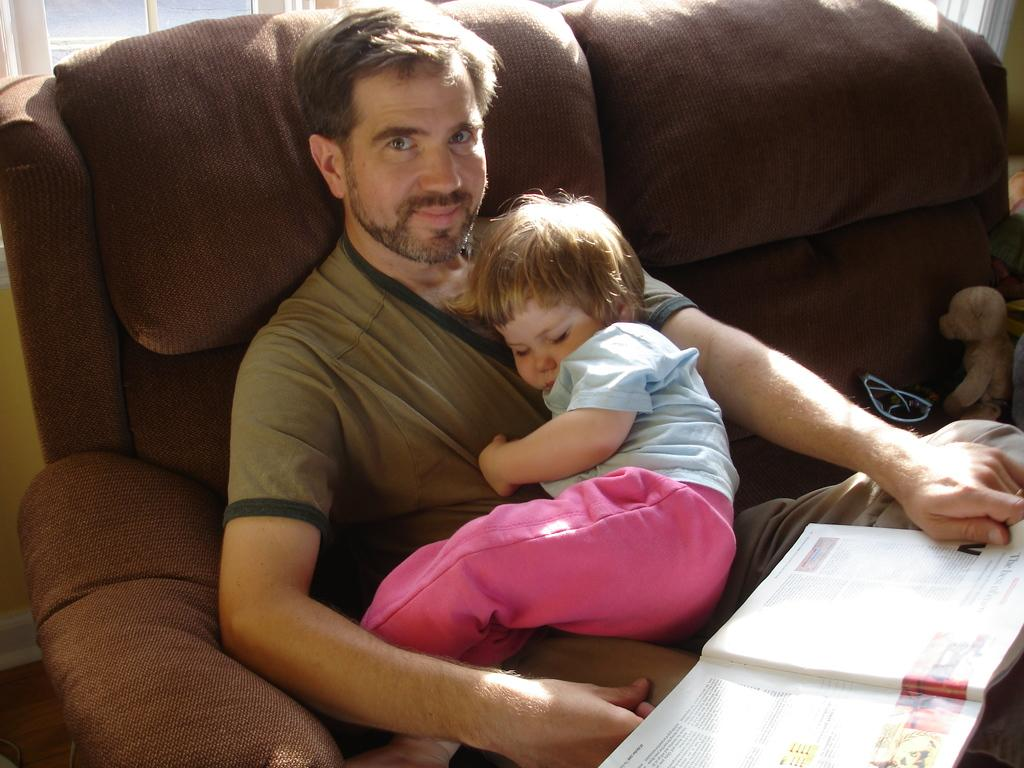What is the person in the image doing? The person is sitting on a couch in the image and holding a baby. What else is the person holding in the image? The person is also holding a book. What objects can be seen on a table or surface in the image? There are glasses and toys visible in the image. What is the background of the image? There is a wall behind the couch and a window visible in the image. What type of grass is growing in the image? There is no grass visible in the image. What degree does the person in the image have? The provided facts do not mention the person's degree or educational background. 